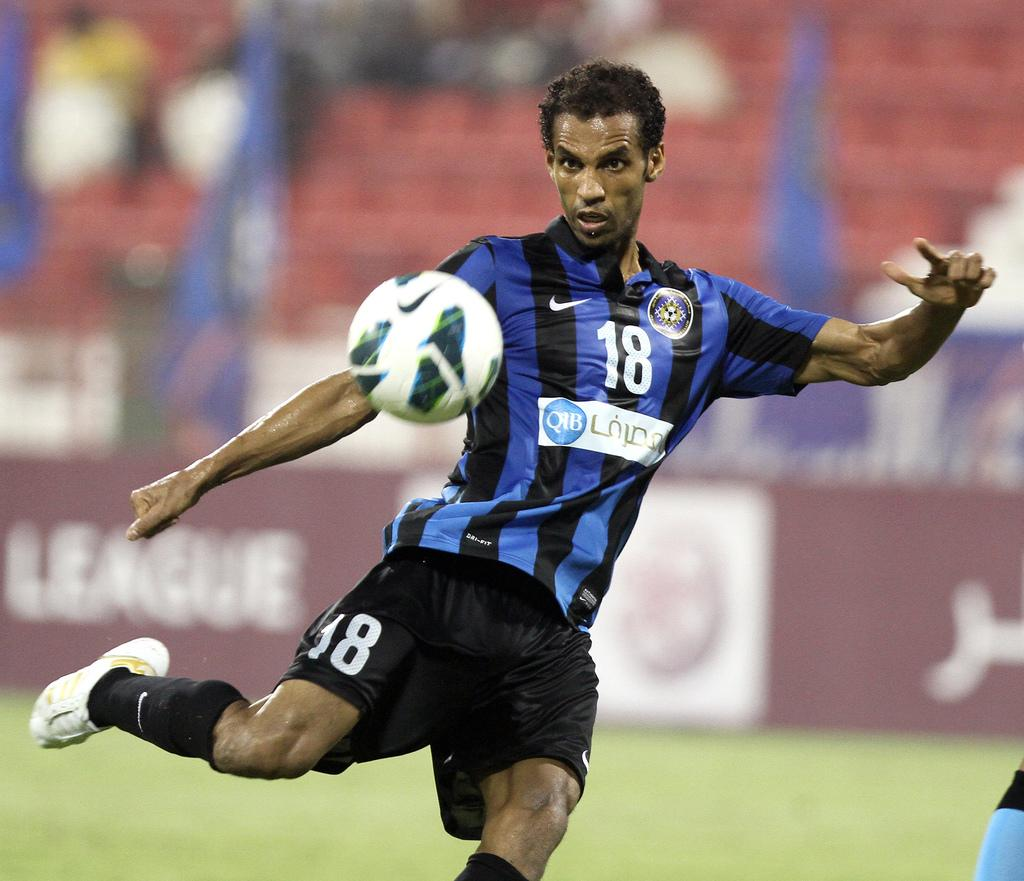Who is the main subject in the image? There is a man in the image. What is the man doing in the image? The man is kicking a football. What type of surface is visible at the bottom of the image? There is grass at the bottom of the image. What can be seen in the background of the image? There is a hoarding and chairs in the background of the image. How would you describe the background of the image? The background appears blurry. What type of bell can be heard ringing in the image? There is no bell present in the image, and therefore no sound can be heard. Can you describe the art displayed on the hoarding in the background? There is no art displayed on the hoarding in the image; it is not mentioned in the provided facts. 